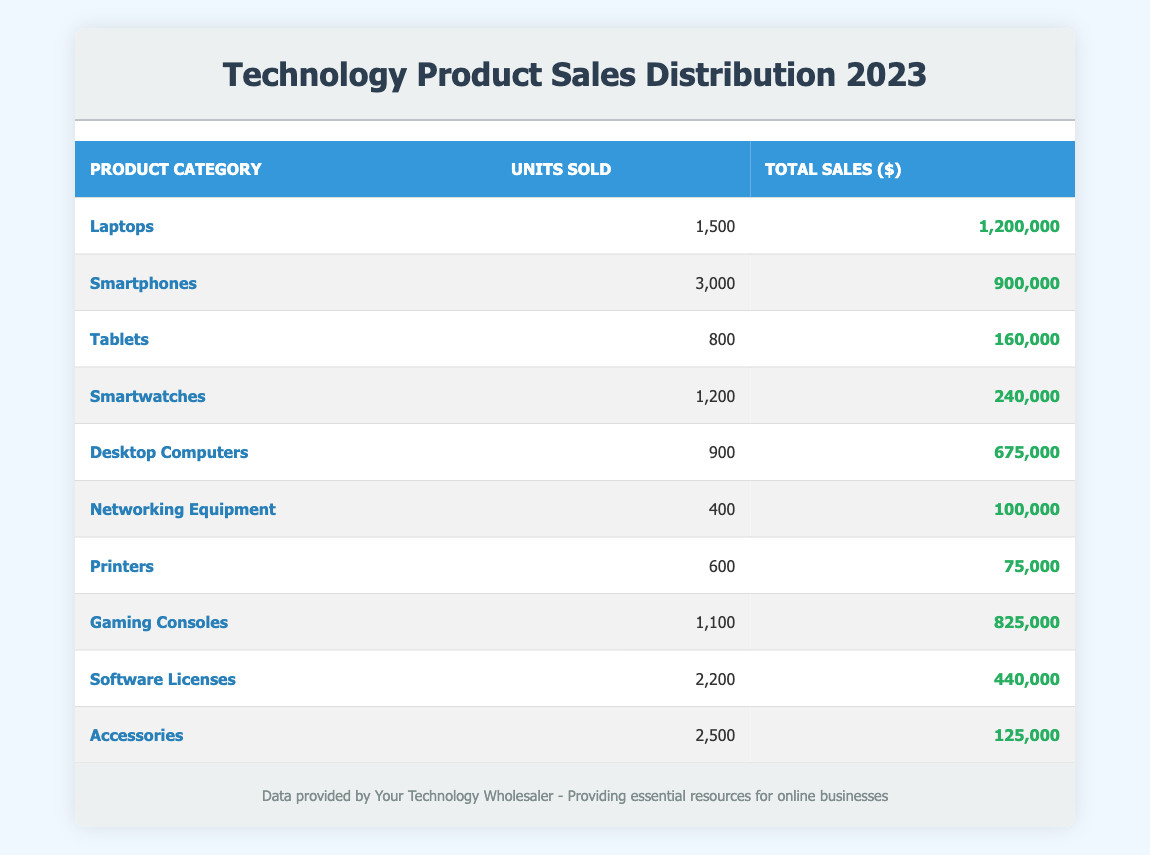What is the total sales amount for Smartphones? From the table, the total sales amount for Smartphones is listed as $900,000.
Answer: 900,000 Which product category sold the highest number of units? The table shows that Smartphones have the highest units sold at 3,000.
Answer: Smartphones What is the difference in total sales between Laptops and Desktops? The total sales for Laptops is $1,200,000 and for Desktops is $675,000. The difference is calculated as $1,200,000 - $675,000 = $525,000.
Answer: 525,000 Did any product category sell fewer than 500 units? Looking at the units sold, Networking Equipment has sold 400 units, which is fewer than 500. Therefore, the answer is yes.
Answer: Yes What is the average total sales amount for all product categories listed in the table? The total sales amount for all categories is calculated by summing them up: $1,200,000 + $900,000 + $160,000 + $240,000 + $675,000 + $100,000 + $75,000 + $825,000 + $440,000 + $125,000 = $4,700,000. Dividing by the number of categories (10), the average total sales amount is $4,700,000 / 10 = $470,000.
Answer: 470,000 Which category sold more: Accessories or Smartwatches? Accessories sold 2,500 units while Smartwatches sold 1,200 units. Since 2,500 is greater than 1,200, Accessories sold more.
Answer: Accessories What percentage of the total sales does Networking Equipment contribute? The total sales sum is $4,700,000. Networking Equipment's sales is $100,000, so the percentage is calculated as ($100,000 / $4,700,000) * 100 ≈ 2.13%.
Answer: 2.13% How many product categories sold more than 1,000 units? The categories that sold more than 1,000 units are Smartphones (3000), Laptops (1500), Accessories (2500), and Software Licenses (2200). This totals 4 categories.
Answer: 4 What is the total number of units sold across all product categories? The total units sold can be summed up: 1500 + 3000 + 800 + 1200 + 900 + 400 + 600 + 1100 + 2200 + 2500 = 11,100.
Answer: 11,100 